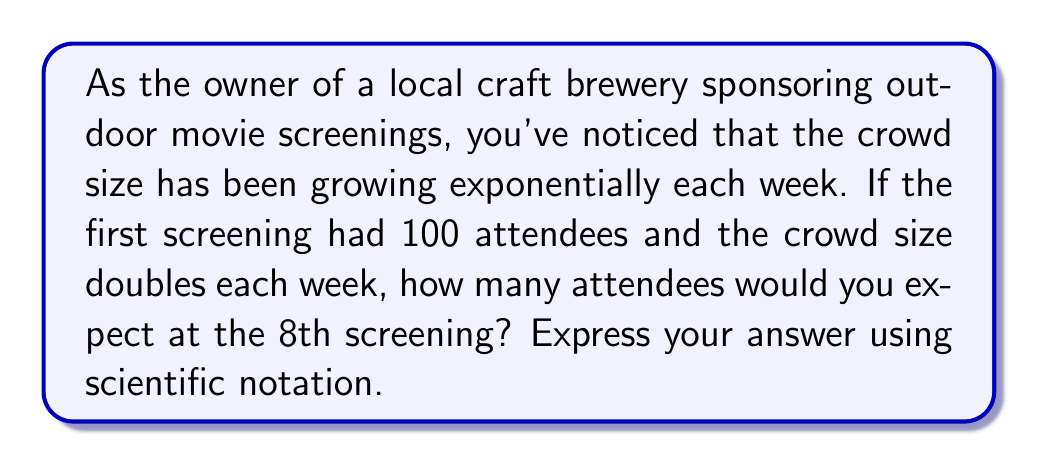What is the answer to this math problem? Let's approach this step-by-step:

1) We start with an initial crowd size of 100 people.

2) The crowd size doubles each week, which means we're dealing with an exponential function with a base of 2.

3) We can express this growth using the exponential function:

   $$ A(n) = 100 \cdot 2^{n-1} $$

   Where $A(n)$ is the attendance at the $n$-th screening.

4) We're asked about the 8th screening, so we need to calculate $A(8)$:

   $$ A(8) = 100 \cdot 2^{8-1} = 100 \cdot 2^7 $$

5) Let's calculate $2^7$:
   
   $$ 2^7 = 2 \cdot 2 \cdot 2 \cdot 2 \cdot 2 \cdot 2 \cdot 2 = 128 $$

6) Now we can complete our calculation:

   $$ A(8) = 100 \cdot 128 = 12,800 $$

7) To express this in scientific notation, we move the decimal point 4 places to the left:

   $$ 12,800 = 1.28 \times 10^4 $$

Therefore, you would expect 12,800 attendees at the 8th screening, or $1.28 \times 10^4$ in scientific notation.
Answer: $1.28 \times 10^4$ attendees 